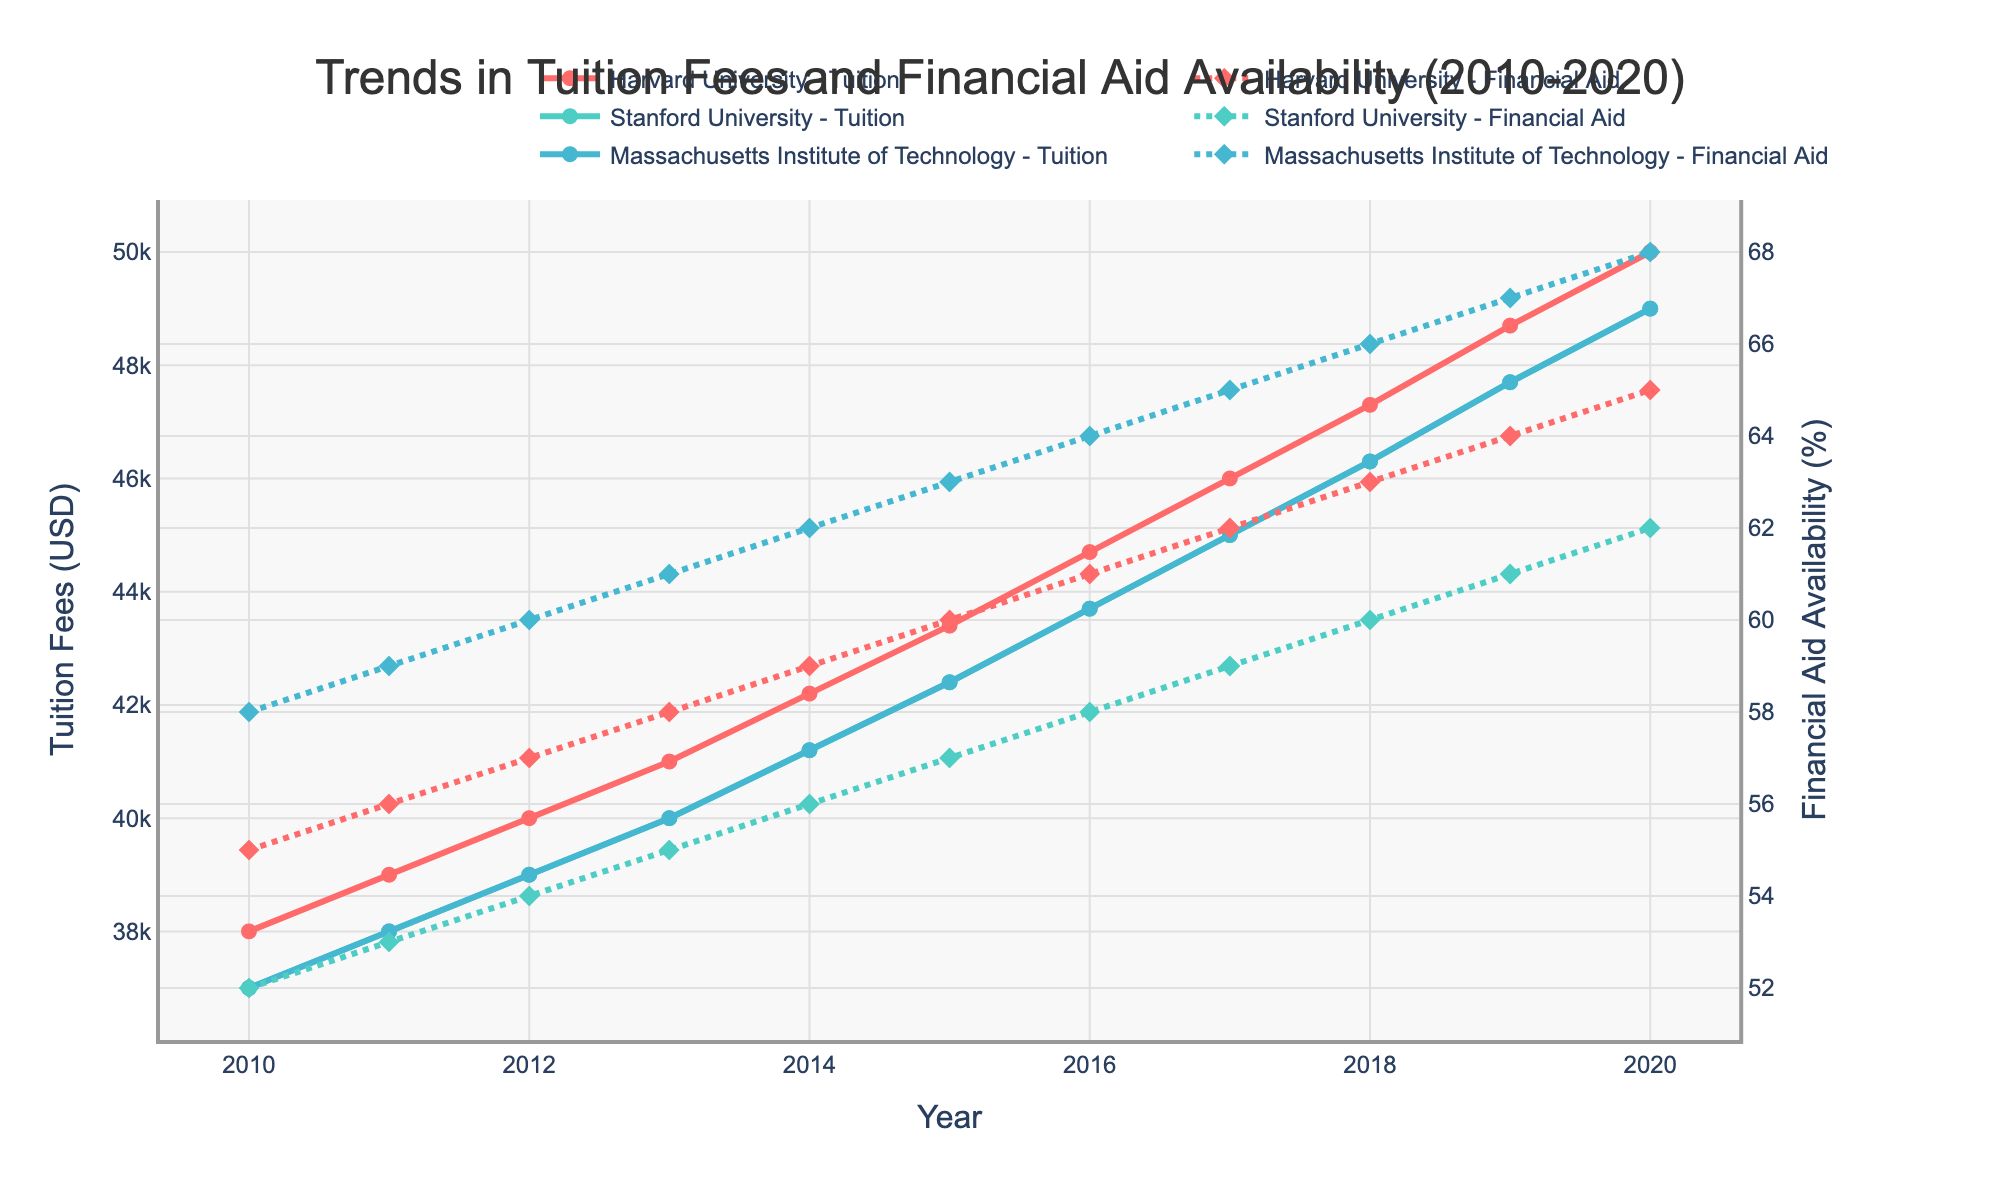How has the tuition fee at Harvard University changed from 2010 to 2020? The tuition fees at Harvard University have increased each year from 2010 to 2020. Starting at $38,000 in 2010 and rising to $50,000 in 2020.
Answer: Increased from $38,000 to $50,000 Which university had the highest tuition fee in 2020? By looking at the tuition fee data for 2020, Harvard University had the highest tuition fee at $50,000.
Answer: Harvard University What is the difference in financial aid availability between MIT and Stanford University in 2015? In 2015, MIT had 63% financial aid availability, while Stanford had 57%. The difference is 63% - 57% = 6%.
Answer: 6% How did the financial aid availability at MIT change over the decade? The financial aid availability at MIT increased from 58% in 2010 to 68% in 2020, showing a consistent year-over-year increase.
Answer: Increased from 58% to 68% Compare the trend of tuition fee changes between Harvard University and Stanford University over the decade. Both universities show an increasing trend in tuition fees over the decade, but Harvard starts higher and ends up higher in 2020. The increase is gradual for both, Harvard starting at $38,000 and ending at $50,000, while Stanford starting at $37,000 and ending at $49,000.
Answer: Both increased, Harvard higher overall What is the overall trend in financial aid availability at Stanford University from 2010 to 2020? The financial aid availability at Stanford University has increased each year, starting at 52% in 2010 and increasing to 62% in 2020.
Answer: Increased from 52% to 62% What is the average tuition fee for MIT over the entire period? The tuition fees for MIT from 2010 to 2020 are: $37,000, $38,000, $39,000, $40,000, $41,200, $42,400, $43,700, $45,000, $46,300, $47,700, and $49,000. The sum is $469,300, and the average is $469,300/11 = $42,663.64.
Answer: $42,663.64 Which year saw the largest increase in tuition fees at Harvard University? The largest increase in tuition fees at Harvard University from one year to the next is $1,500, observed between 2019 ($48,700) and 2020 ($50,000).
Answer: 2020 How does the financial aid availability for MIT in 2020 compare to that of Harvard University in the same year? In 2020, MIT had a 68% financial aid availability, while Harvard University had 65%. MIT's financial aid availability was higher by 3%.
Answer: MIT is higher by 3% How do the tuition fees of MIT and Stanford University compare in 2015? In 2015, both MIT and Stanford University have the same tuition fee of $42,400.
Answer: Both are the same 